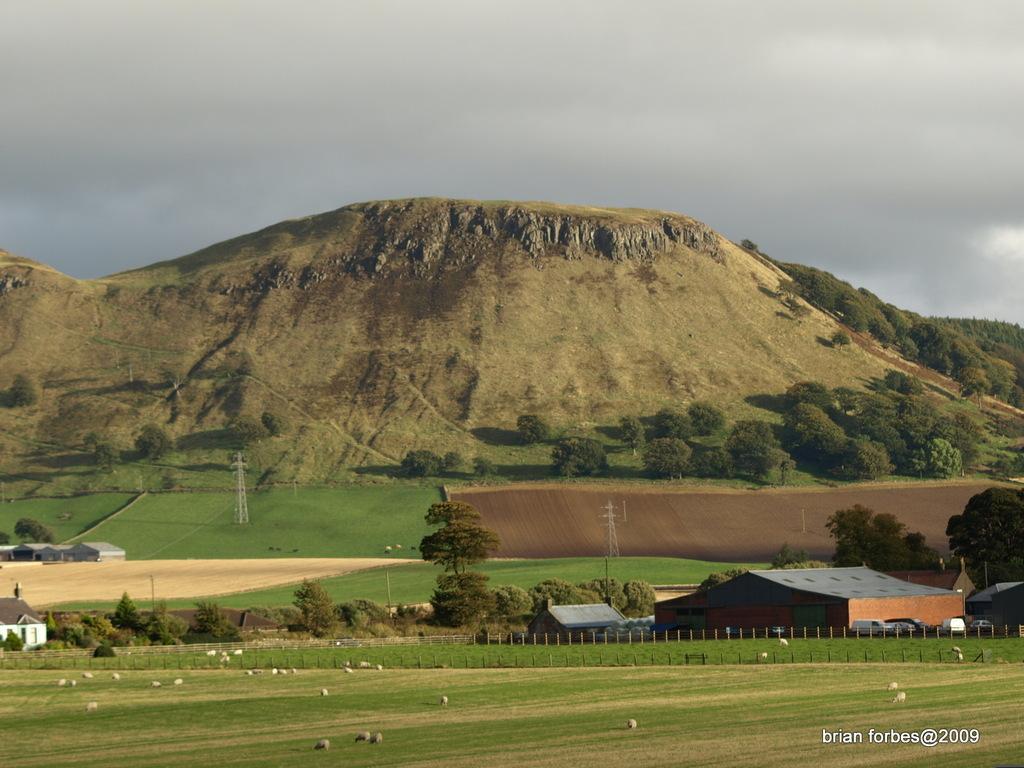How would you summarize this image in a sentence or two? In the center of the image we can see the mountains, trees, towers, grass, houses, some vehicles, fencing and some animals. At the bottom of the image we can see the ground. In the bottom right corner we can see some text. At the top of the image we can see the clouds are present in the sky. 